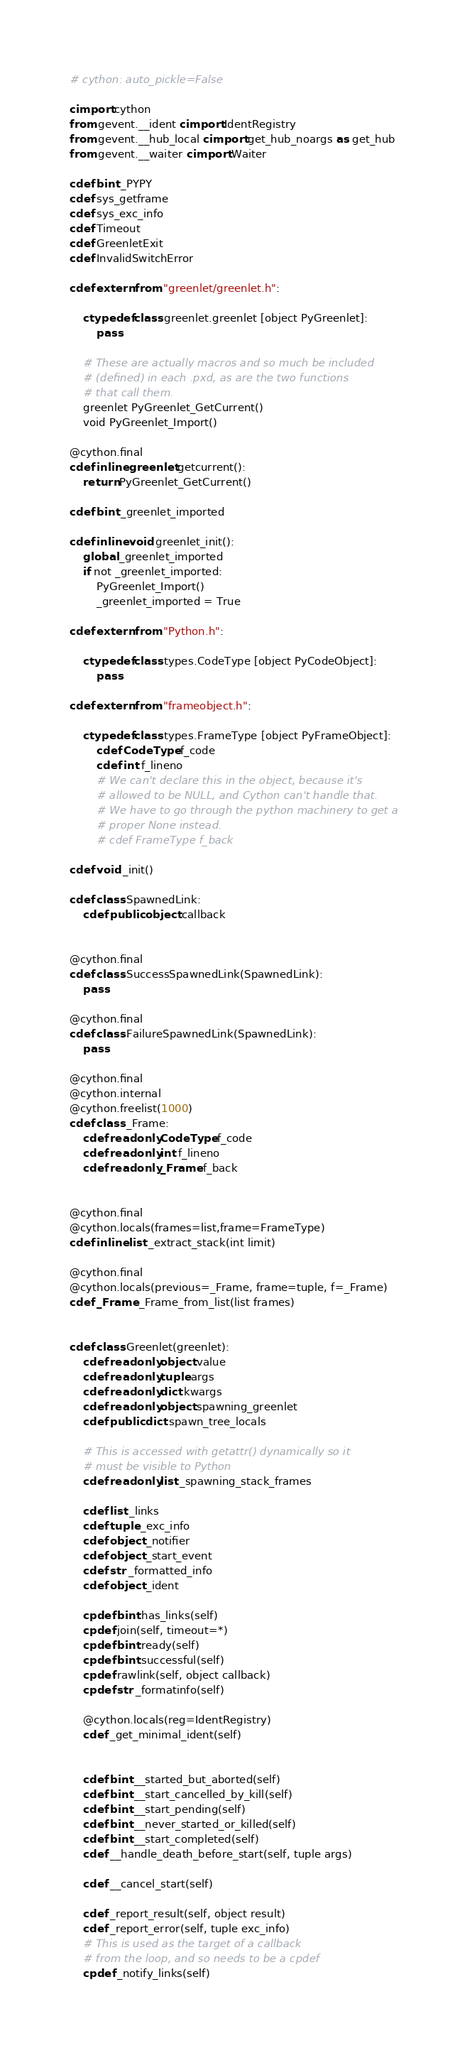<code> <loc_0><loc_0><loc_500><loc_500><_Cython_># cython: auto_pickle=False

cimport cython
from gevent.__ident cimport IdentRegistry
from gevent.__hub_local cimport get_hub_noargs as get_hub
from gevent.__waiter cimport Waiter

cdef bint _PYPY
cdef sys_getframe
cdef sys_exc_info
cdef Timeout
cdef GreenletExit
cdef InvalidSwitchError

cdef extern from "greenlet/greenlet.h":

    ctypedef class greenlet.greenlet [object PyGreenlet]:
        pass

    # These are actually macros and so much be included
    # (defined) in each .pxd, as are the two functions
    # that call them.
    greenlet PyGreenlet_GetCurrent()
    void PyGreenlet_Import()

@cython.final
cdef inline greenlet getcurrent():
    return PyGreenlet_GetCurrent()

cdef bint _greenlet_imported

cdef inline void greenlet_init():
    global _greenlet_imported
    if not _greenlet_imported:
        PyGreenlet_Import()
        _greenlet_imported = True

cdef extern from "Python.h":

    ctypedef class types.CodeType [object PyCodeObject]:
        pass

cdef extern from "frameobject.h":

    ctypedef class types.FrameType [object PyFrameObject]:
        cdef CodeType f_code
        cdef int f_lineno
        # We can't declare this in the object, because it's
        # allowed to be NULL, and Cython can't handle that.
        # We have to go through the python machinery to get a
        # proper None instead.
        # cdef FrameType f_back

cdef void _init()

cdef class SpawnedLink:
    cdef public object callback


@cython.final
cdef class SuccessSpawnedLink(SpawnedLink):
    pass

@cython.final
cdef class FailureSpawnedLink(SpawnedLink):
    pass

@cython.final
@cython.internal
@cython.freelist(1000)
cdef class _Frame:
    cdef readonly CodeType f_code
    cdef readonly int f_lineno
    cdef readonly _Frame f_back


@cython.final
@cython.locals(frames=list,frame=FrameType)
cdef inline list _extract_stack(int limit)

@cython.final
@cython.locals(previous=_Frame, frame=tuple, f=_Frame)
cdef _Frame _Frame_from_list(list frames)


cdef class Greenlet(greenlet):
    cdef readonly object value
    cdef readonly tuple args
    cdef readonly dict kwargs
    cdef readonly object spawning_greenlet
    cdef public dict spawn_tree_locals

    # This is accessed with getattr() dynamically so it
    # must be visible to Python
    cdef readonly list _spawning_stack_frames

    cdef list _links
    cdef tuple _exc_info
    cdef object _notifier
    cdef object _start_event
    cdef str _formatted_info
    cdef object _ident

    cpdef bint has_links(self)
    cpdef join(self, timeout=*)
    cpdef bint ready(self)
    cpdef bint successful(self)
    cpdef rawlink(self, object callback)
    cpdef str _formatinfo(self)

    @cython.locals(reg=IdentRegistry)
    cdef _get_minimal_ident(self)


    cdef bint __started_but_aborted(self)
    cdef bint __start_cancelled_by_kill(self)
    cdef bint __start_pending(self)
    cdef bint __never_started_or_killed(self)
    cdef bint __start_completed(self)
    cdef __handle_death_before_start(self, tuple args)

    cdef __cancel_start(self)

    cdef _report_result(self, object result)
    cdef _report_error(self, tuple exc_info)
    # This is used as the target of a callback
    # from the loop, and so needs to be a cpdef
    cpdef _notify_links(self)
</code> 